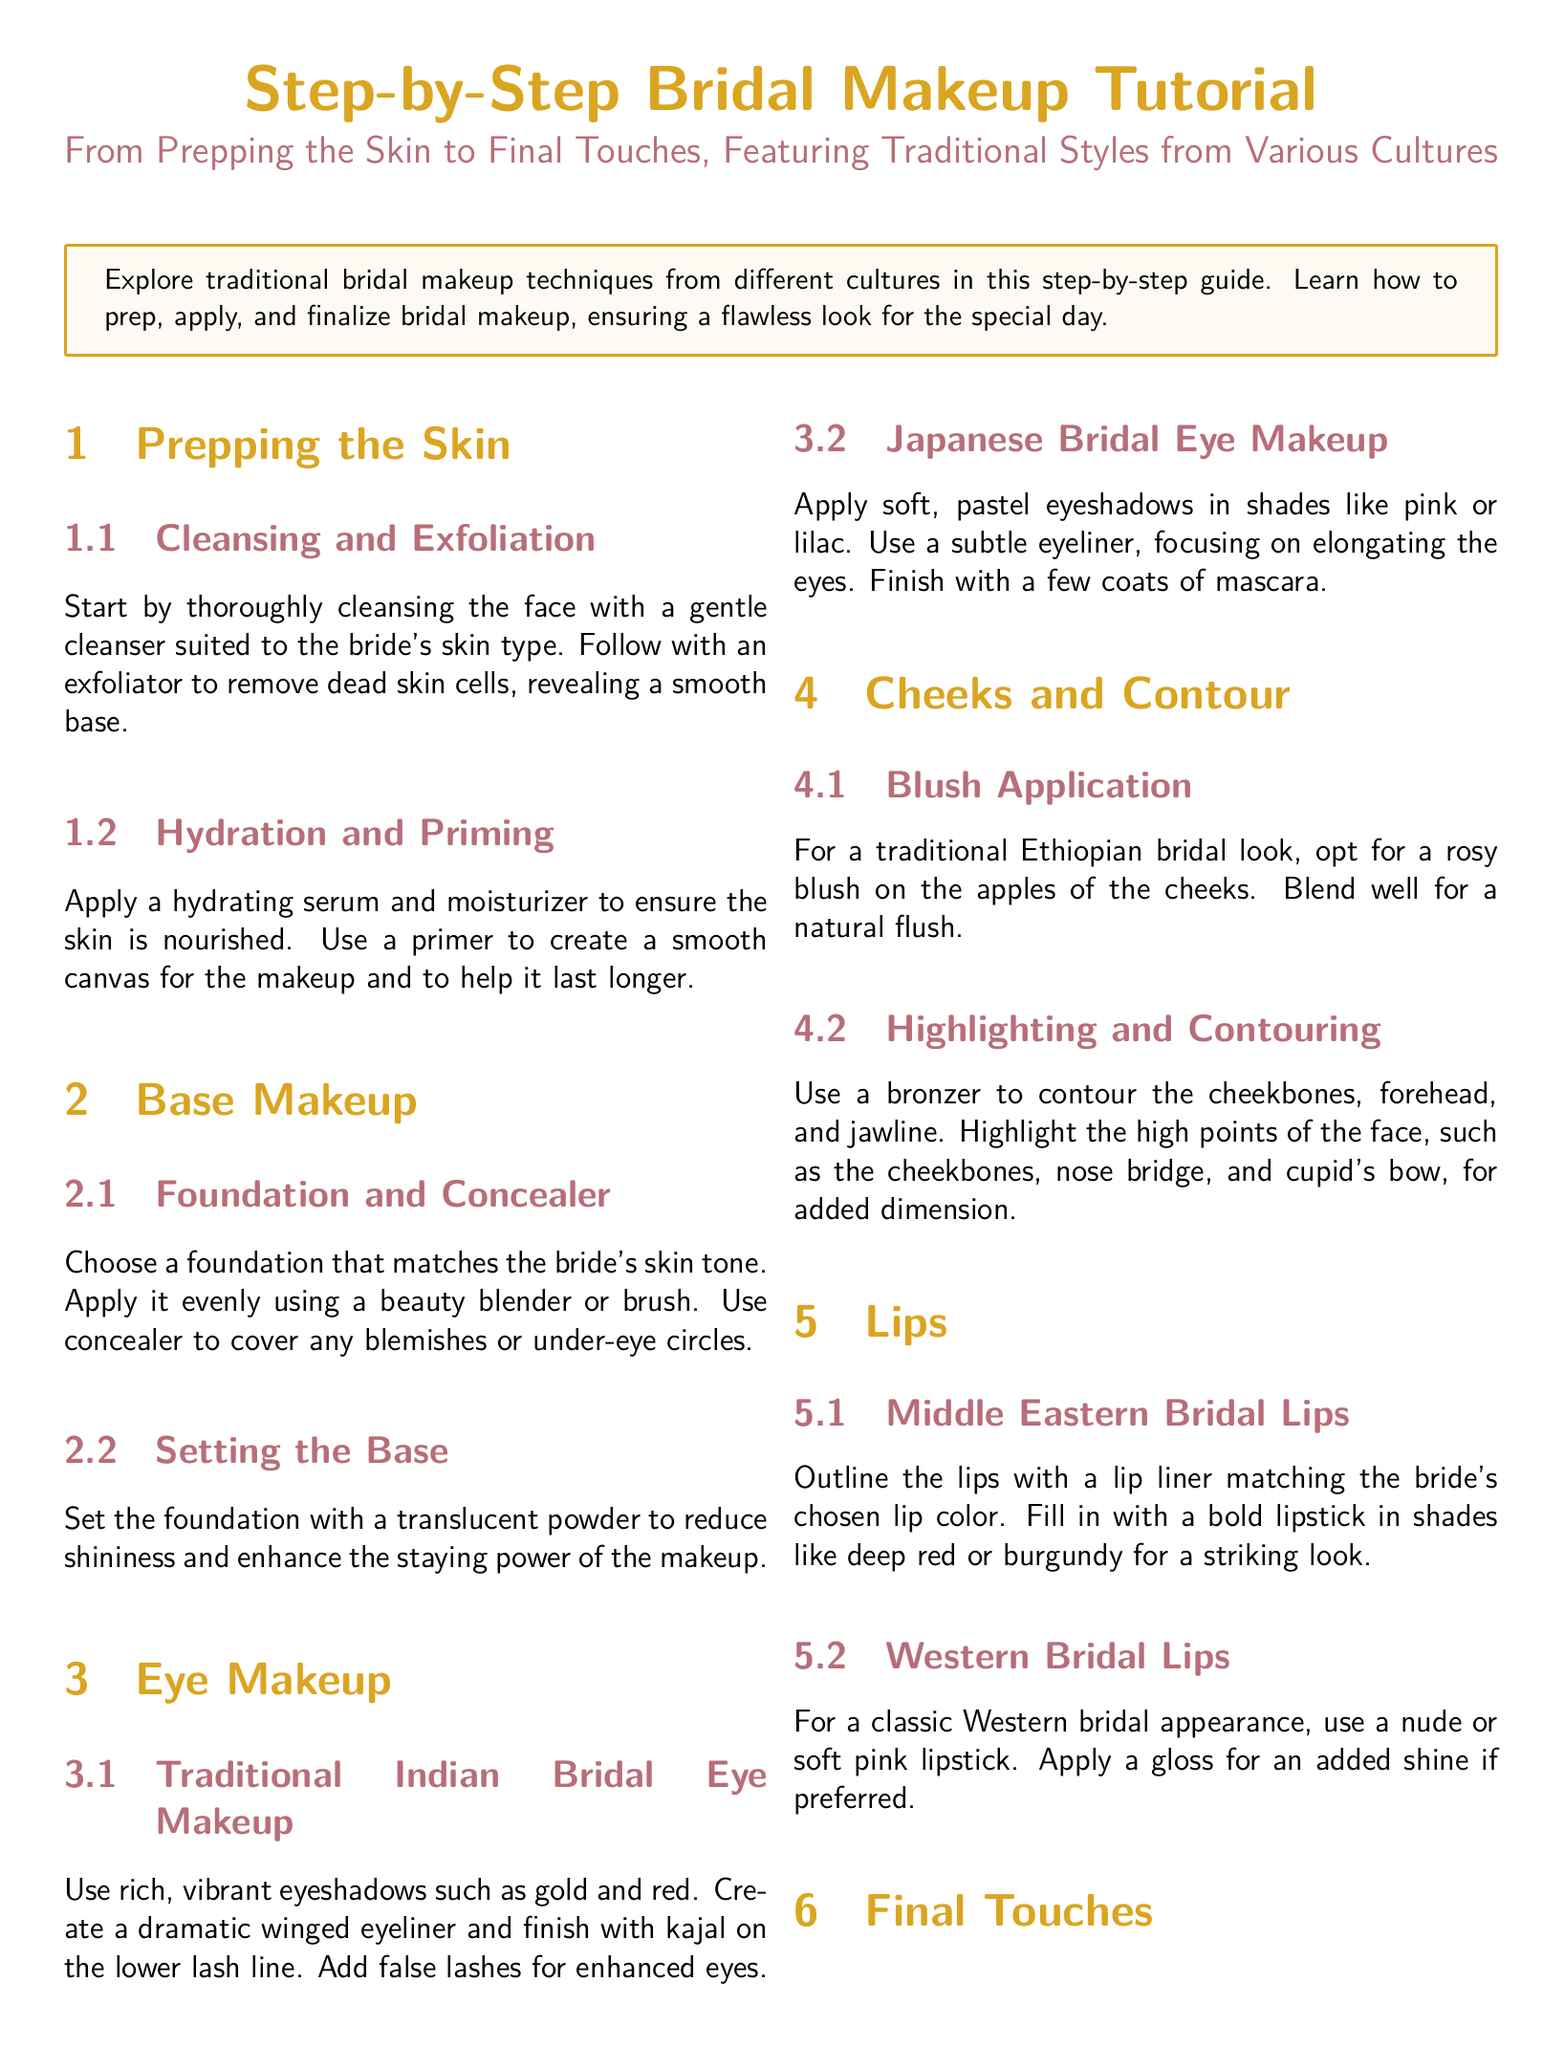What is the main focus of the tutorial? The tutorial focuses on traditional bridal makeup techniques from different cultures.
Answer: Traditional bridal makeup techniques How should the skin be prepared before applying makeup? The document states to cleanse the face and follow with exfoliation.
Answer: Cleansing and exfoliation What type of eyeshadow is used in traditional Indian bridal eye makeup? The tutorial specifies using rich, vibrant eyeshadows like gold and red.
Answer: Gold and red What is applied to lock the makeup in place? The document mentions using a setting spray to help the makeup last longer.
Answer: Setting spray Which lip color is recommended for Middle Eastern bridal lips? It suggests using bold lipstick in shades like deep red or burgundy.
Answer: Deep red or burgundy What traditional item is added to the hair for final touches? The document indicates adding hair accessories like flowers, beads, or tiaras.
Answer: Flowers, beads, or tiaras What should be used to create a smooth canvas for makeup? The tutorial advises using a primer after hydration.
Answer: Primer Which culture's bridal makeup uses pastel eyeshadows? The tutorial mentions Japanese bridal makeup using soft, pastel eyeshadows.
Answer: Japanese What is recommended for highlighting the face? The document suggests using a highlighter on the high points of the face.
Answer: Highlighter 